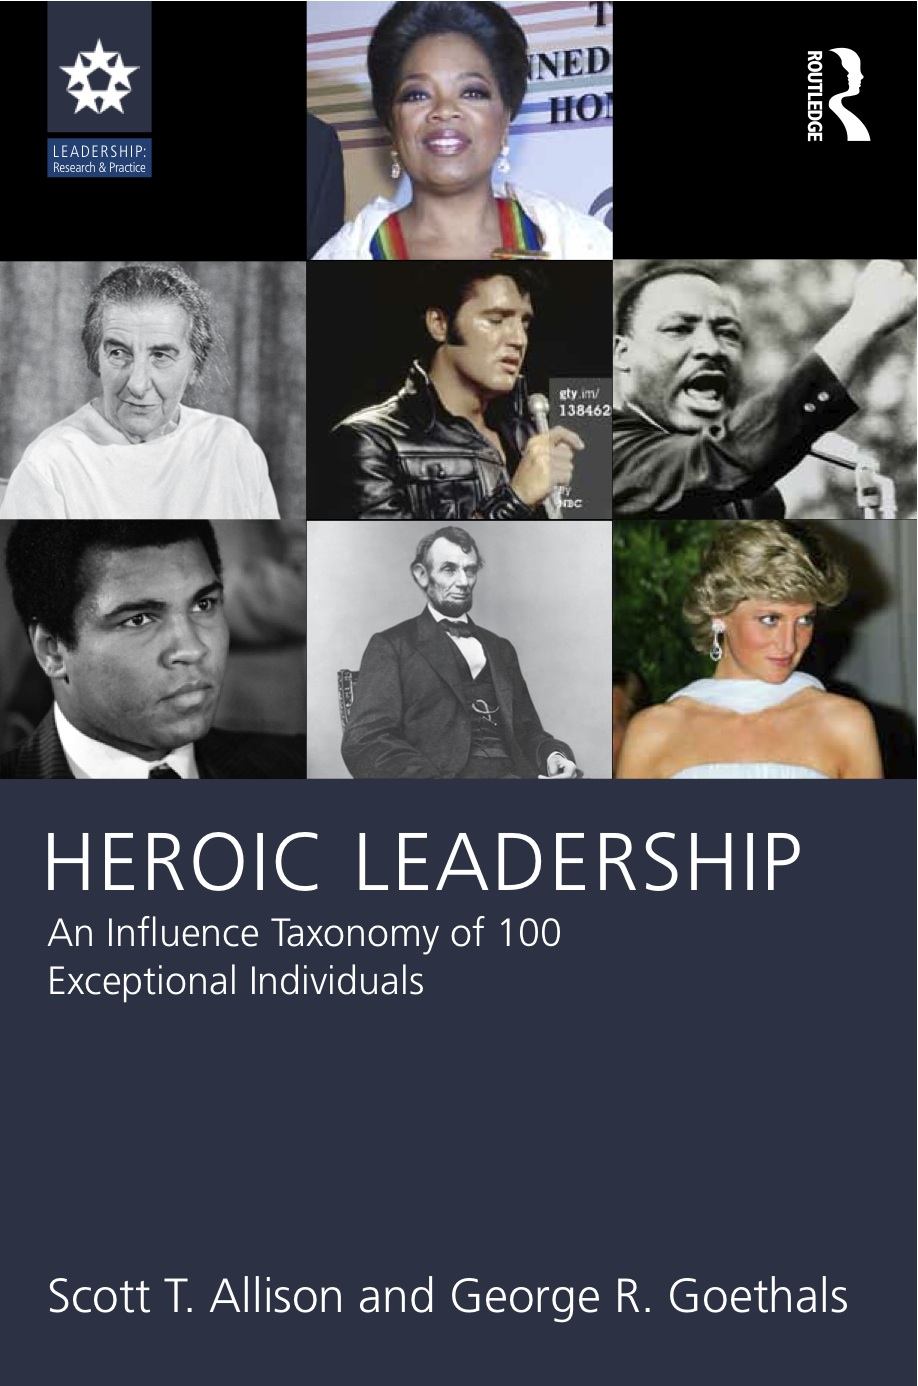Based on the composition of the cover, what might be the criteria for the selection of individuals featured on the book cover, and how do they collectively represent the concept of "Heroic Leadership"? The individuals featured on the book cover are likely selected based on their profound impact on society, their global recognition as leaders or icons, and their diverse contributions across different eras and sectors. Collectively, they exemplify 'Heroic Leadership' by possessing and demonstrating qualities such as resilience, courage, moral integrity, and the ability to inspire and effectuate change through their actions and legacies. Each figure showcased might have chapters dedicated to their specific leadership traits, educational backgrounds, challenges faced and how they influenced the world, thereby offering a multifaceted exploration of what it means to lead heroically in varying circumstances. 